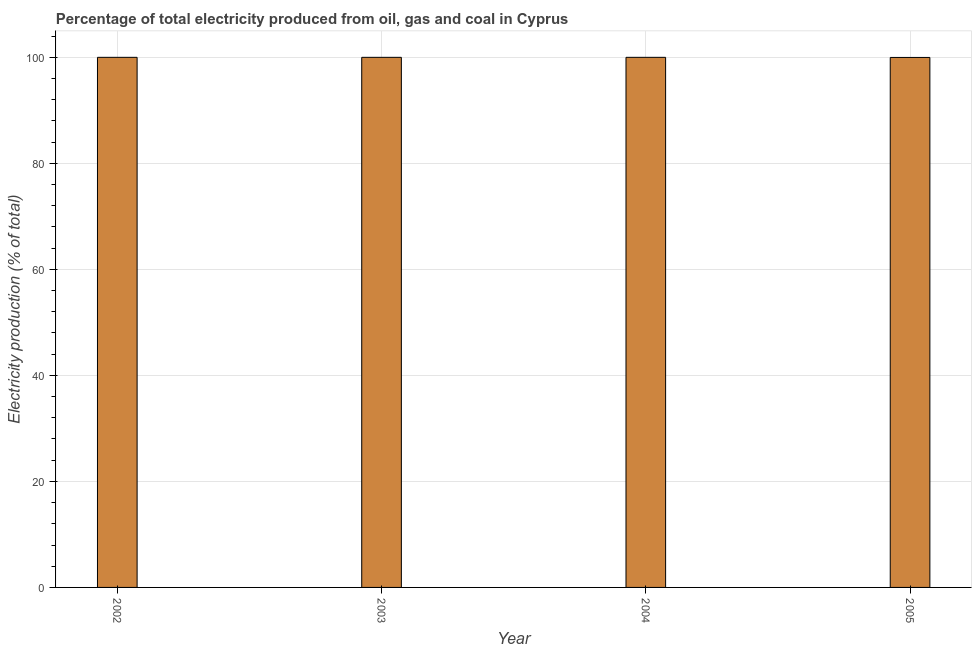Does the graph contain any zero values?
Offer a terse response. No. Does the graph contain grids?
Offer a terse response. Yes. What is the title of the graph?
Offer a terse response. Percentage of total electricity produced from oil, gas and coal in Cyprus. What is the label or title of the Y-axis?
Ensure brevity in your answer.  Electricity production (% of total). What is the electricity production in 2005?
Keep it short and to the point. 99.98. Across all years, what is the maximum electricity production?
Your response must be concise. 100. Across all years, what is the minimum electricity production?
Give a very brief answer. 99.98. In which year was the electricity production minimum?
Your response must be concise. 2005. What is the sum of the electricity production?
Offer a terse response. 399.98. What is the difference between the electricity production in 2002 and 2005?
Your response must be concise. 0.02. What is the average electricity production per year?
Offer a terse response. 99.99. What is the median electricity production?
Keep it short and to the point. 100. In how many years, is the electricity production greater than 88 %?
Provide a short and direct response. 4. Do a majority of the years between 2004 and 2005 (inclusive) have electricity production greater than 92 %?
Provide a short and direct response. Yes. Is the sum of the electricity production in 2002 and 2005 greater than the maximum electricity production across all years?
Make the answer very short. Yes. What is the difference between the highest and the lowest electricity production?
Keep it short and to the point. 0.02. In how many years, is the electricity production greater than the average electricity production taken over all years?
Offer a terse response. 3. How many years are there in the graph?
Your response must be concise. 4. What is the difference between two consecutive major ticks on the Y-axis?
Your response must be concise. 20. What is the Electricity production (% of total) of 2004?
Your response must be concise. 100. What is the Electricity production (% of total) of 2005?
Make the answer very short. 99.98. What is the difference between the Electricity production (% of total) in 2002 and 2004?
Provide a short and direct response. 0. What is the difference between the Electricity production (% of total) in 2002 and 2005?
Ensure brevity in your answer.  0.02. What is the difference between the Electricity production (% of total) in 2003 and 2005?
Your answer should be compact. 0.02. What is the difference between the Electricity production (% of total) in 2004 and 2005?
Ensure brevity in your answer.  0.02. What is the ratio of the Electricity production (% of total) in 2002 to that in 2005?
Provide a short and direct response. 1. What is the ratio of the Electricity production (% of total) in 2003 to that in 2004?
Make the answer very short. 1. What is the ratio of the Electricity production (% of total) in 2003 to that in 2005?
Provide a short and direct response. 1. What is the ratio of the Electricity production (% of total) in 2004 to that in 2005?
Provide a succinct answer. 1. 